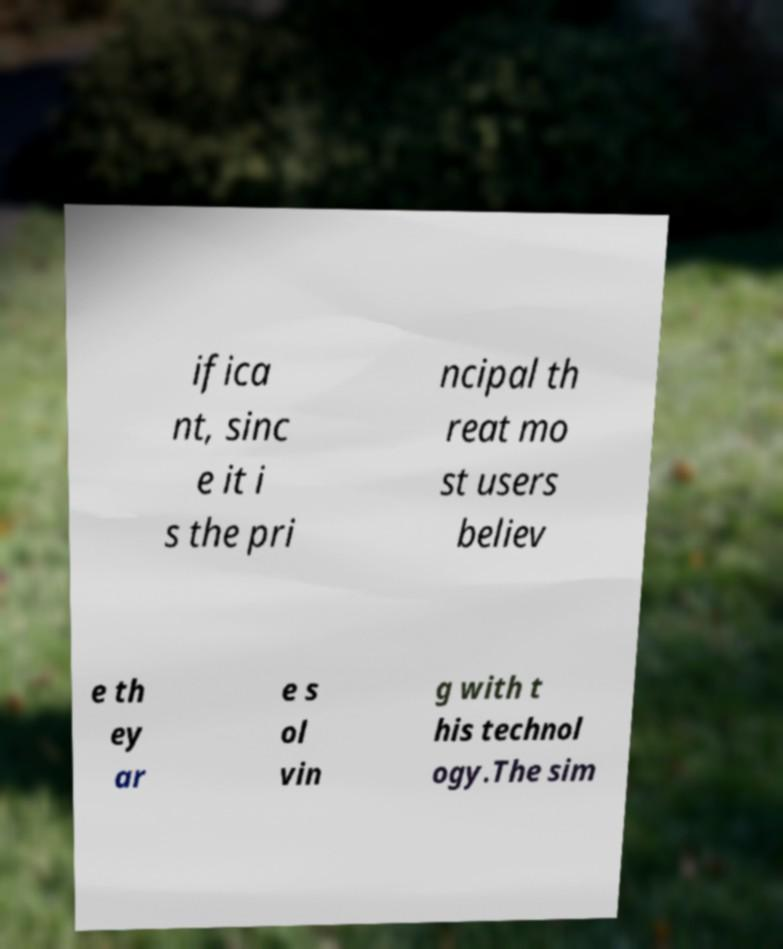There's text embedded in this image that I need extracted. Can you transcribe it verbatim? ifica nt, sinc e it i s the pri ncipal th reat mo st users believ e th ey ar e s ol vin g with t his technol ogy.The sim 